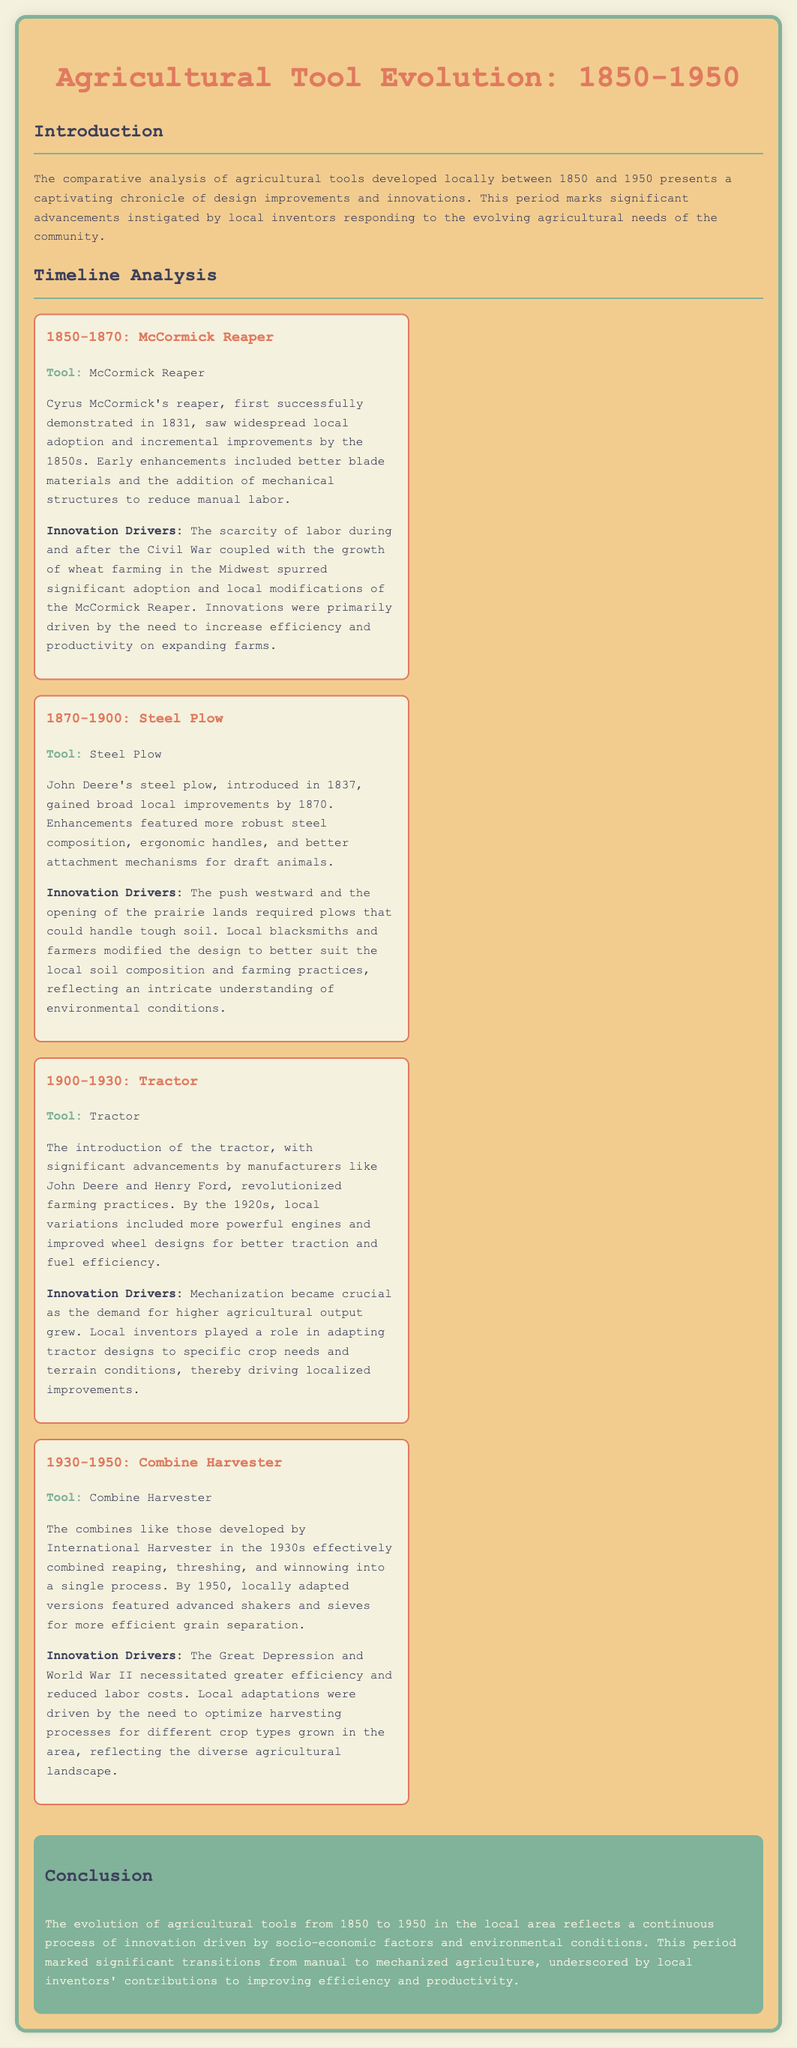What tool was introduced between 1850 and 1870? The document states that the McCormick Reaper was the tool developed during this period.
Answer: McCormick Reaper Who developed the steel plow? According to the document, John Deere is identified as the developer of the steel plow.
Answer: John Deere What significant tool was introduced in 1900? The document mentions that the tractor was the significant tool introduced in this time frame.
Answer: Tractor What innovation driver characterized the period of 1930 to 1950? The document indicates that efficiency and reduced labor costs were key drivers for innovations during this time.
Answer: Efficiency and reduced labor costs What was a local adaptation of the tractor? The document highlights that local variations included more powerful engines and improved wheel designs for better traction.
Answer: More powerful engines and improved wheel designs What societal challenge influenced the adoption of the McCormick Reaper? The document notes that the scarcity of labor during and after the Civil War influenced the adoption of the McCormick Reaper.
Answer: Scarcity of labor What did the example of the combine harvester demonstrate? The document explains that the combine harvester effectively combined reaping, threshing, and winnowing into a single process.
Answer: Combined reaping, threshing, and winnowing What crucial need spurred the development of the steel plow? The document states that the push westward and the opening of prairie lands created this crucial need.
Answer: Push westward and opening of prairie lands Which invention reflects a transition to mechanized agriculture mentioned in the conclusion? The document concludes that the evolution of agricultural tools reflects this transition.
Answer: Mechanized agriculture 